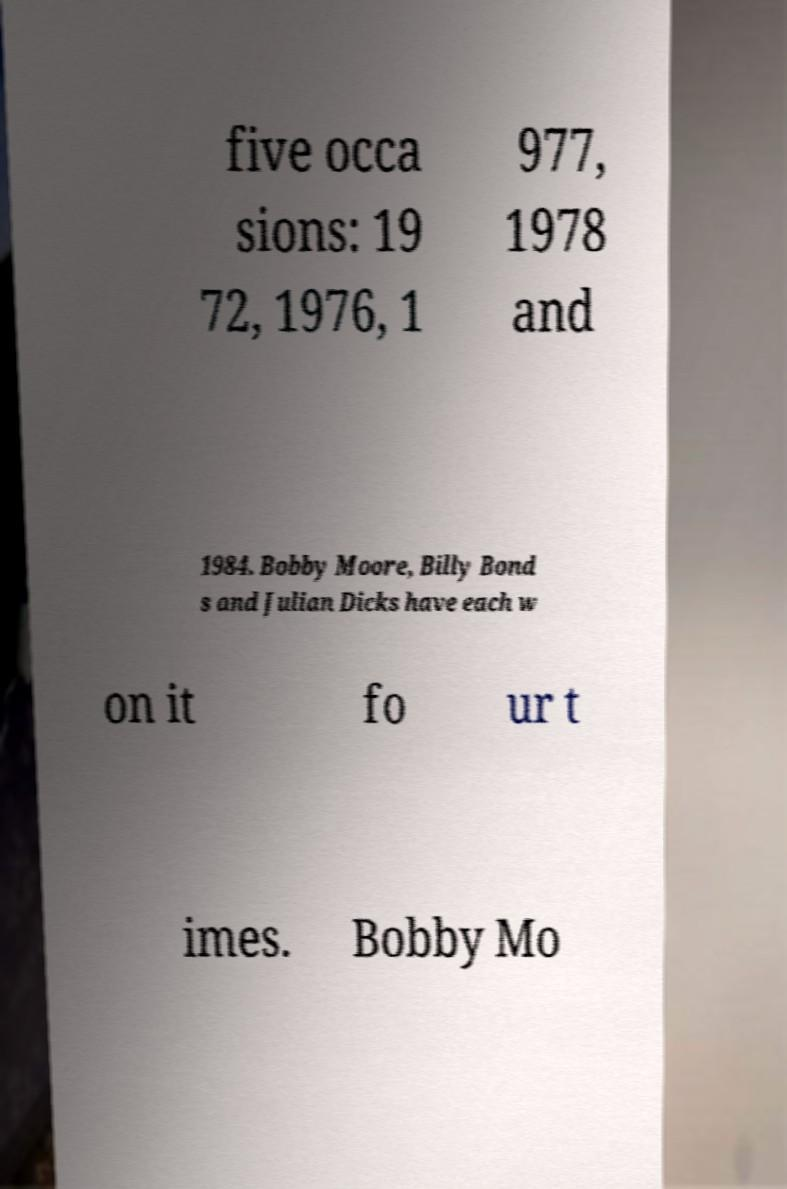For documentation purposes, I need the text within this image transcribed. Could you provide that? five occa sions: 19 72, 1976, 1 977, 1978 and 1984. Bobby Moore, Billy Bond s and Julian Dicks have each w on it fo ur t imes. Bobby Mo 